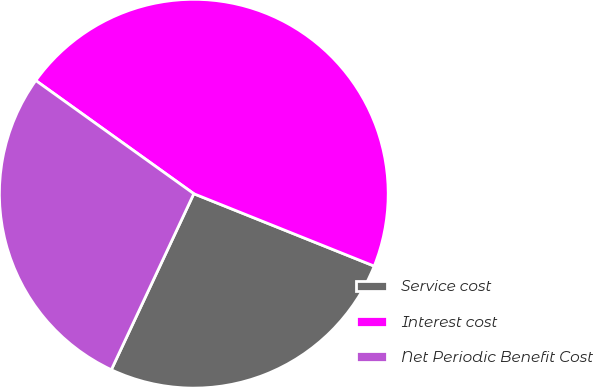<chart> <loc_0><loc_0><loc_500><loc_500><pie_chart><fcel>Service cost<fcel>Interest cost<fcel>Net Periodic Benefit Cost<nl><fcel>25.9%<fcel>46.18%<fcel>27.92%<nl></chart> 